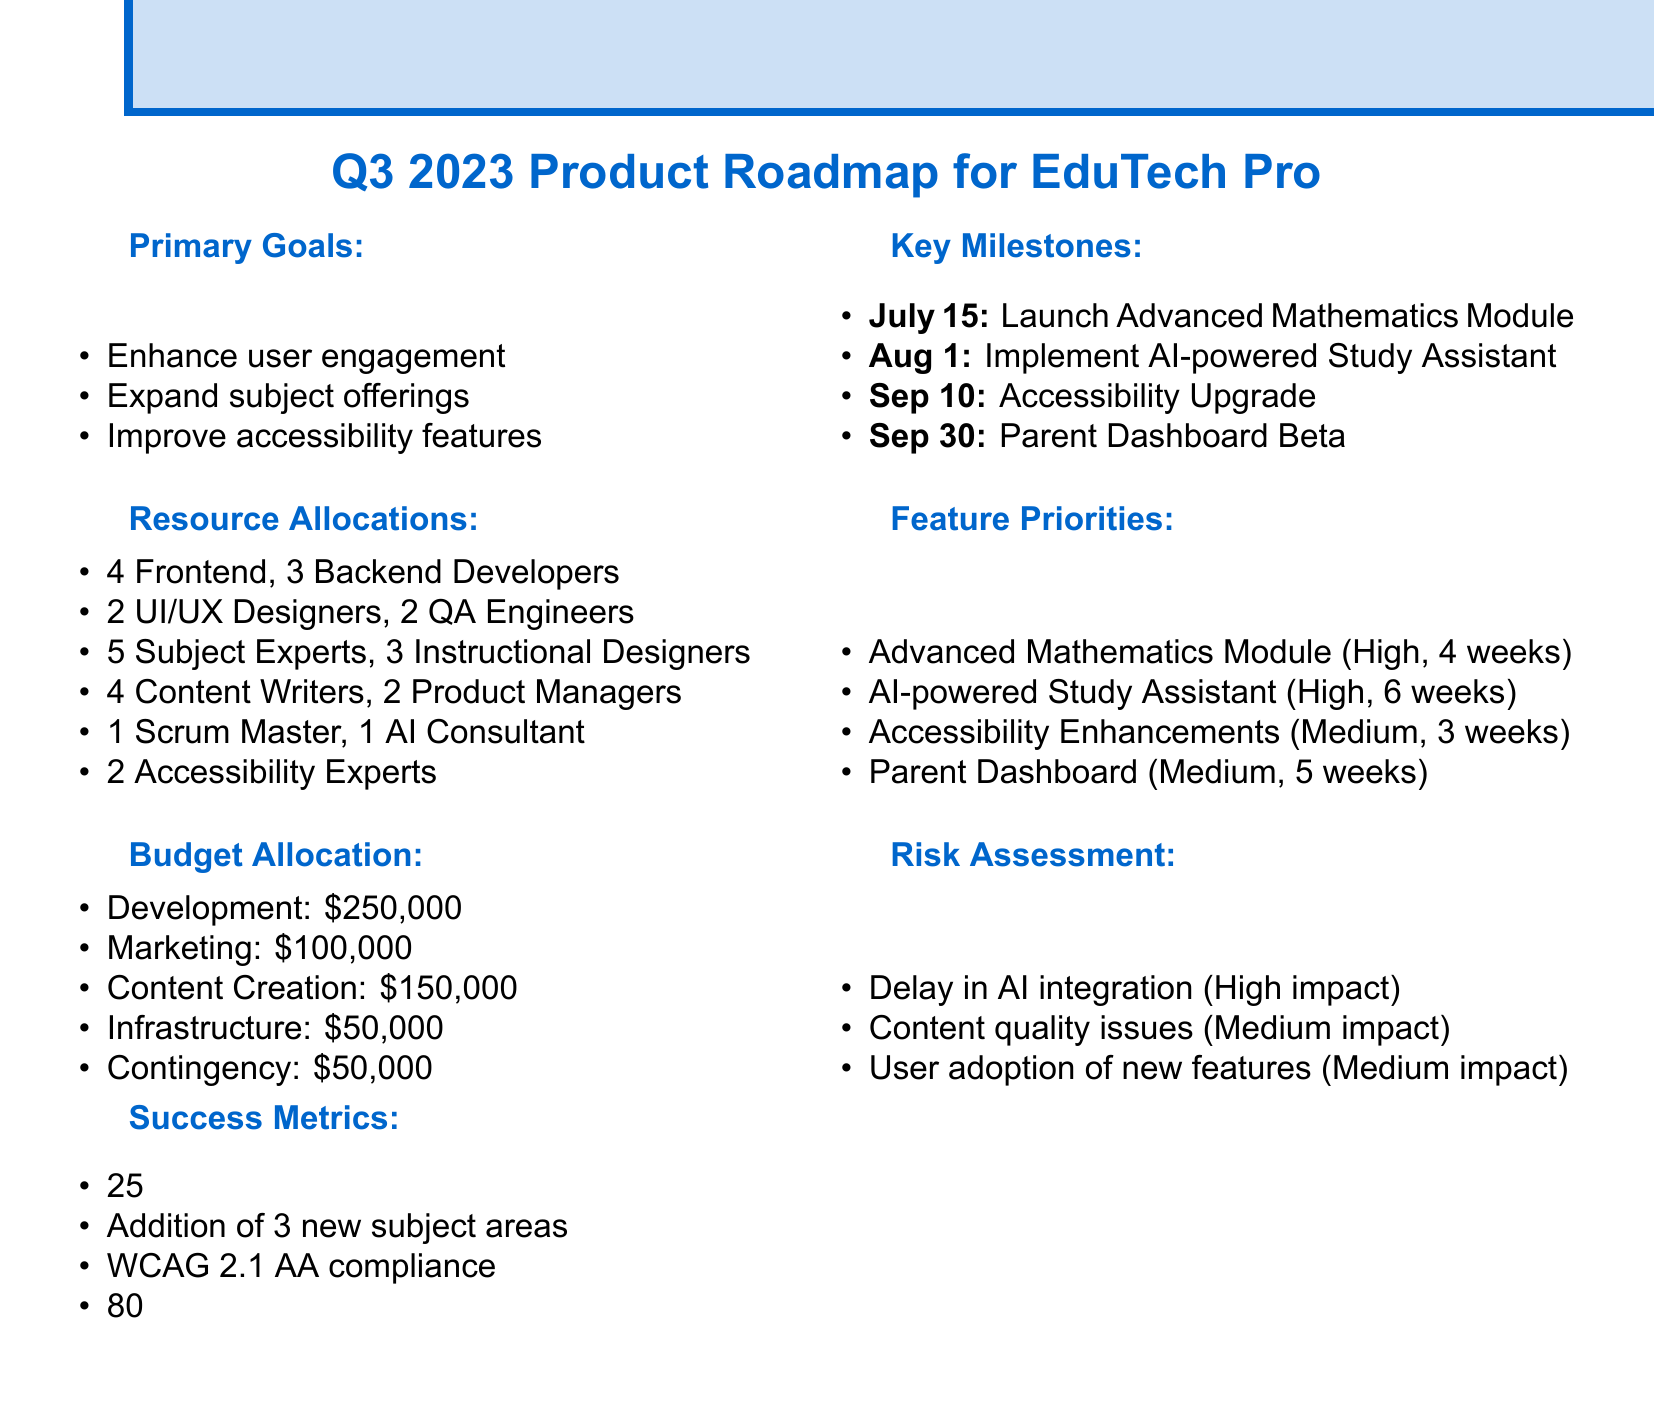What is the title of the document? The title is specified in the roadmap overview section of the document.
Answer: Q3 2023 Product Roadmap for EduTech Pro What is the deadline for the launch of the Advanced Mathematics Module? The deadline is listed as part of the key milestones section.
Answer: July 15, 2023 How many frontend developers are allocated in the resource allocations? The number of frontend developers is provided in the resource allocations section.
Answer: 4 What is the priority of the AI-powered Study Assistant feature? The priority level for this feature is detailed in the feature priorities section.
Answer: High What is the budget allocation for marketing? The budget is specified under the budget allocation section of the document.
Answer: $100,000 What is the target increase in daily active users? This target is mentioned under the success metrics section in the document.
Answer: 25% increase What is the estimated development time for the Parent Dashboard? The estimated time is outlined in the feature priorities section of the document.
Answer: 5 weeks What impact level is assigned to the risk of "Delay in AI integration"? The impact level is described in the risk assessment section.
Answer: High How many QA engineers are included in the development team? This number is provided in the resource allocations section of the document.
Answer: 2 